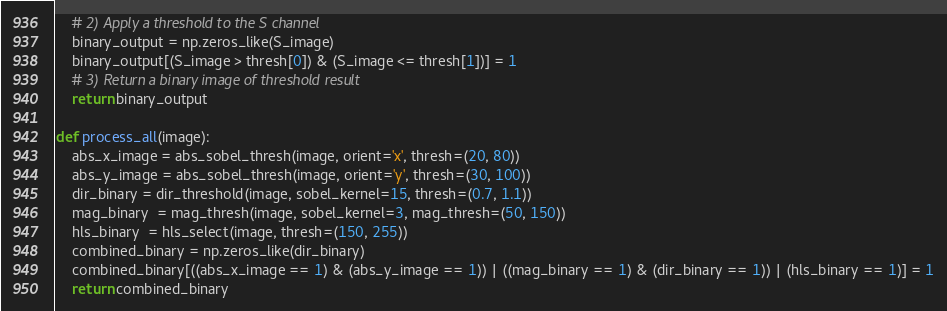<code> <loc_0><loc_0><loc_500><loc_500><_Python_>    # 2) Apply a threshold to the S channel
    binary_output = np.zeros_like(S_image)
    binary_output[(S_image > thresh[0]) & (S_image <= thresh[1])] = 1
    # 3) Return a binary image of threshold result
    return binary_output

def process_all(image):
    abs_x_image = abs_sobel_thresh(image, orient='x', thresh=(20, 80))
    abs_y_image = abs_sobel_thresh(image, orient='y', thresh=(30, 100))
    dir_binary = dir_threshold(image, sobel_kernel=15, thresh=(0.7, 1.1))
    mag_binary  = mag_thresh(image, sobel_kernel=3, mag_thresh=(50, 150))
    hls_binary  = hls_select(image, thresh=(150, 255))
    combined_binary = np.zeros_like(dir_binary)
    combined_binary[((abs_x_image == 1) & (abs_y_image == 1)) | ((mag_binary == 1) & (dir_binary == 1)) | (hls_binary == 1)] = 1
    return combined_binary

</code> 